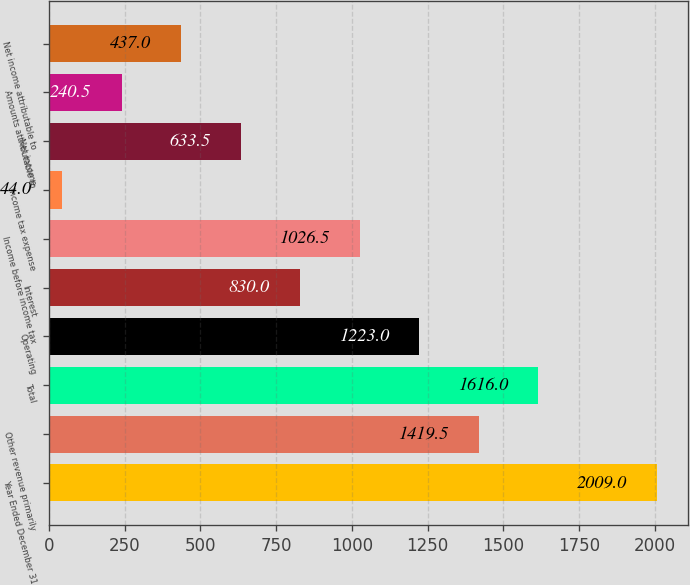Convert chart to OTSL. <chart><loc_0><loc_0><loc_500><loc_500><bar_chart><fcel>Year Ended December 31<fcel>Other revenue primarily<fcel>Total<fcel>Operating<fcel>Interest<fcel>Income before income tax<fcel>Income tax expense<fcel>Net income<fcel>Amounts attributable to<fcel>Net income attributable to<nl><fcel>2009<fcel>1419.5<fcel>1616<fcel>1223<fcel>830<fcel>1026.5<fcel>44<fcel>633.5<fcel>240.5<fcel>437<nl></chart> 